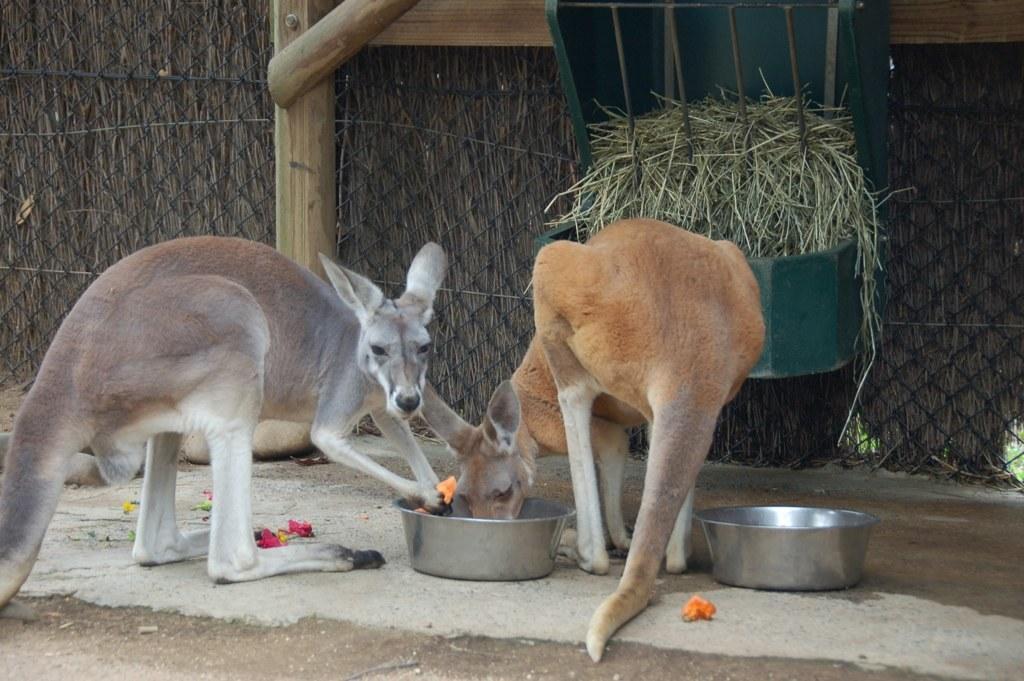Please provide a concise description of this image. In the image there are two kangaroos eating some food from a dish and behind the kangaroos there is a grass kept in a basket and behind that there is a mesh. 